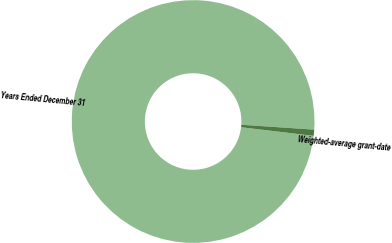<chart> <loc_0><loc_0><loc_500><loc_500><pie_chart><fcel>Years Ended December 31<fcel>Weighted-average grant-date<nl><fcel>99.18%<fcel>0.82%<nl></chart> 